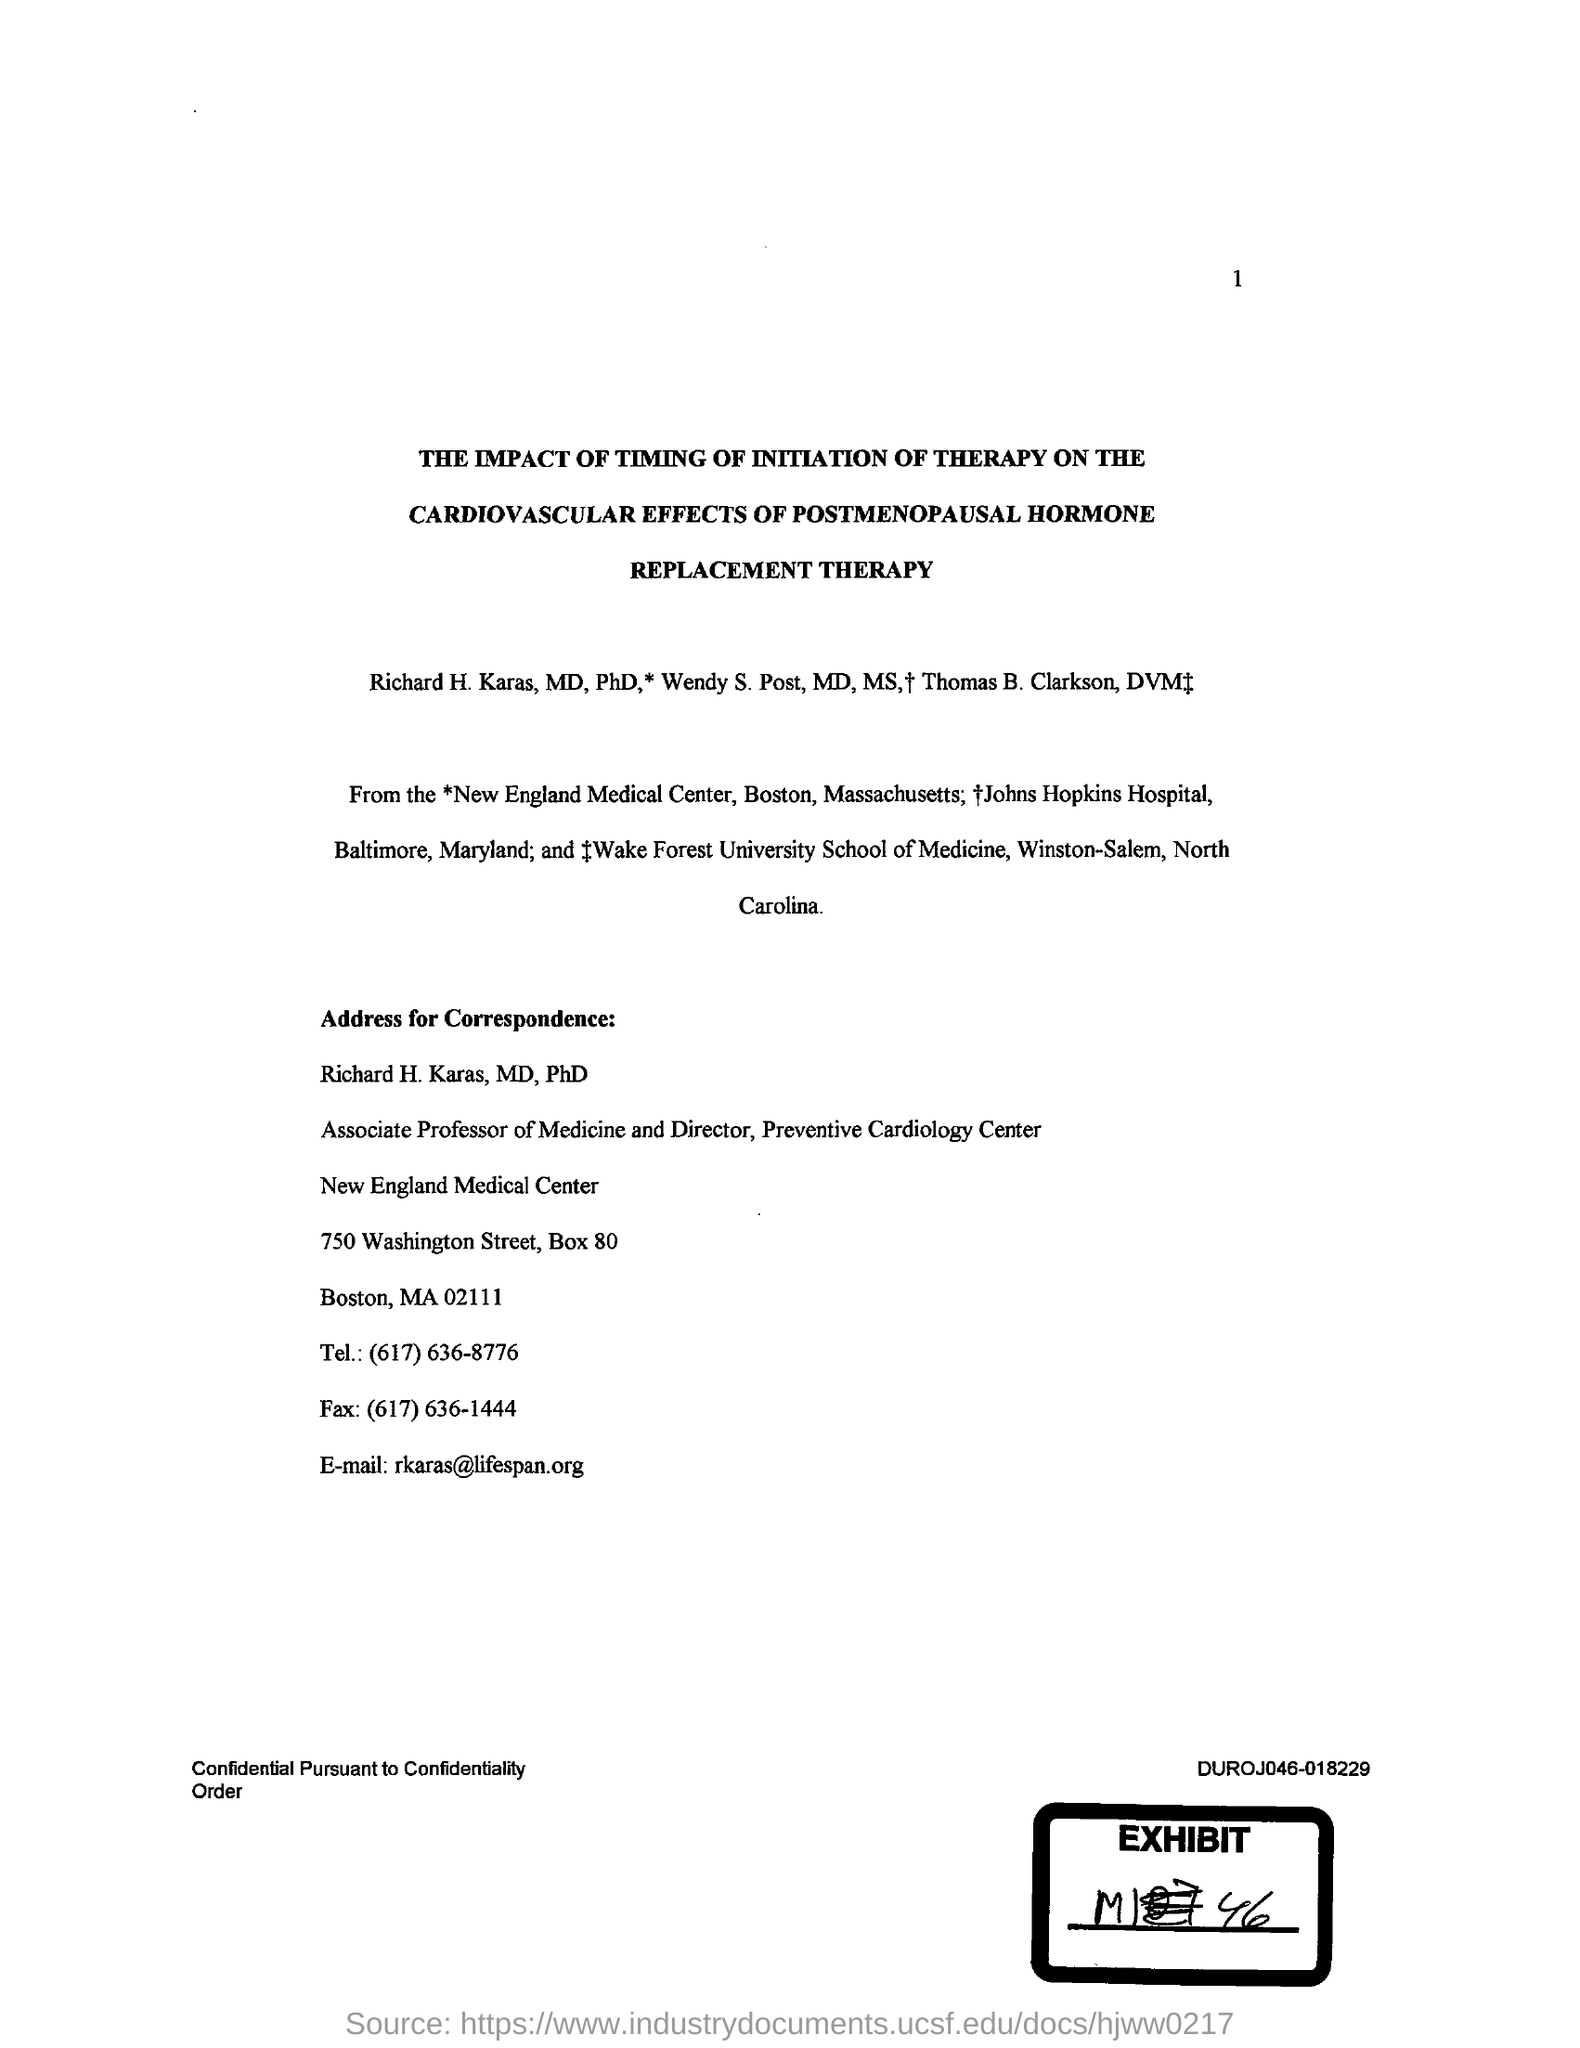What is the telephone number given?
Offer a terse response. (617) 636-8776. What is the Fax number given?
Your answer should be very brief. (617) 636-1444. What is the email address given?
Your response must be concise. Rkaras@lifespan.org. 